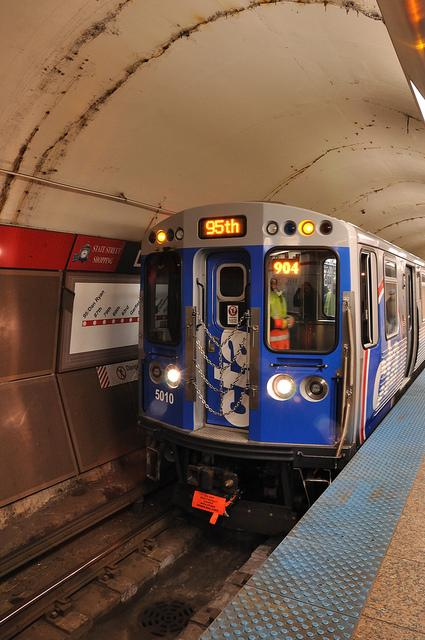In what US city is this subway station located in? chicago 